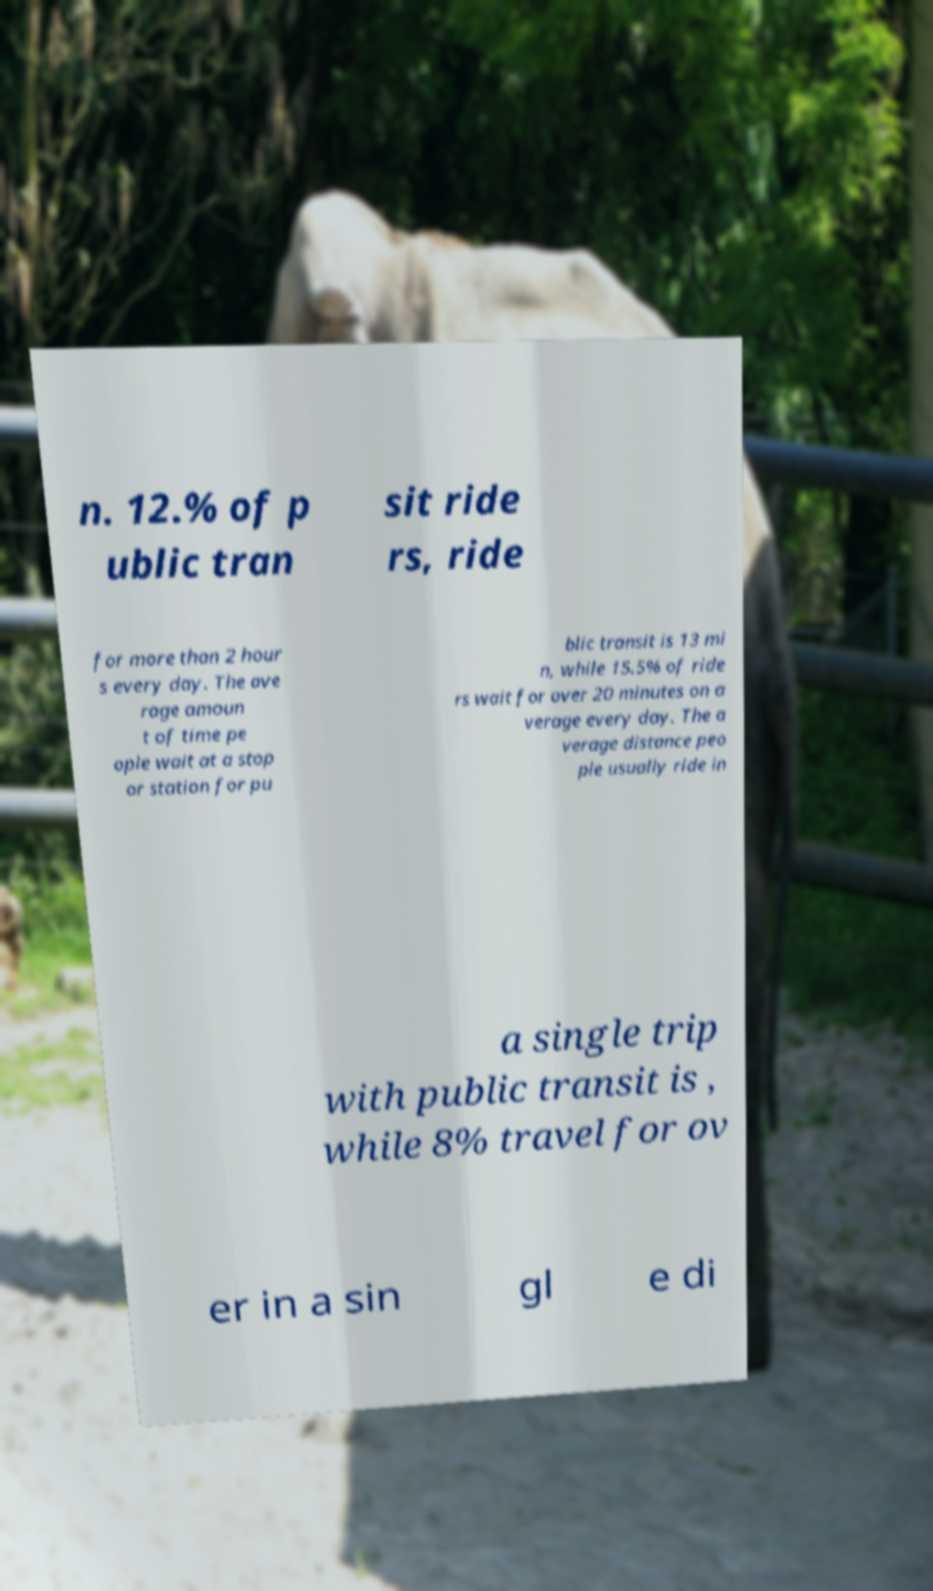Could you assist in decoding the text presented in this image and type it out clearly? n. 12.% of p ublic tran sit ride rs, ride for more than 2 hour s every day. The ave rage amoun t of time pe ople wait at a stop or station for pu blic transit is 13 mi n, while 15.5% of ride rs wait for over 20 minutes on a verage every day. The a verage distance peo ple usually ride in a single trip with public transit is , while 8% travel for ov er in a sin gl e di 